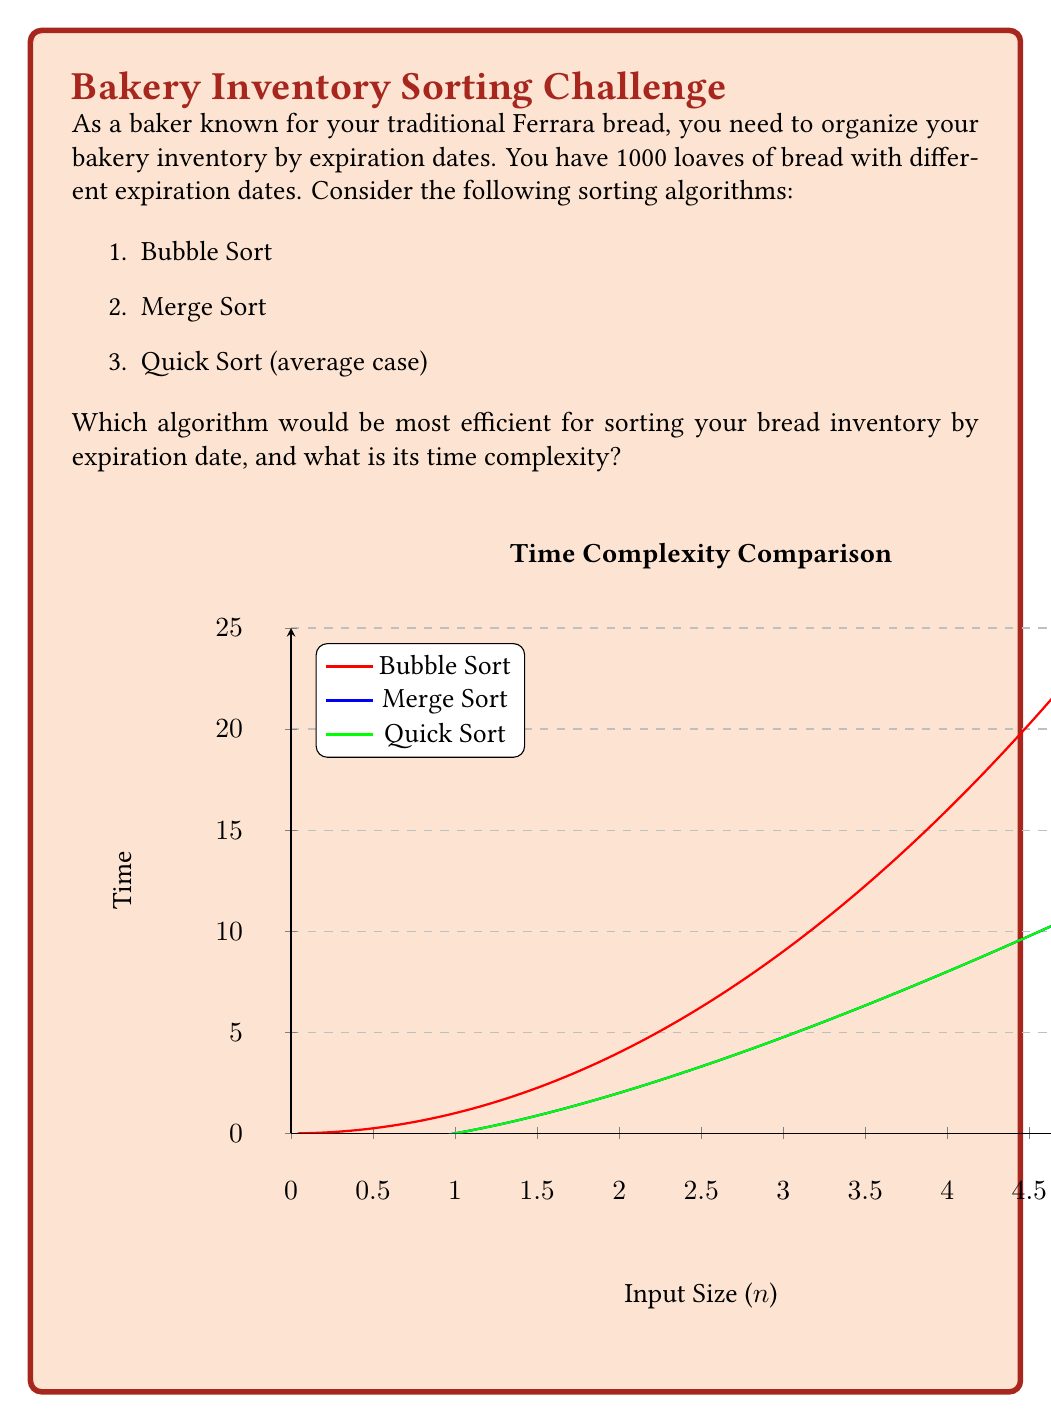Can you solve this math problem? Let's analyze the time complexity of each sorting algorithm:

1. Bubble Sort:
   - Time complexity: $O(n^2)$
   - For 1000 loaves: $1000^2 = 1,000,000$ operations

2. Merge Sort:
   - Time complexity: $O(n \log n)$
   - For 1000 loaves: $1000 \log_2 1000 \approx 9,966$ operations

3. Quick Sort (average case):
   - Time complexity: $O(n \log n)$
   - For 1000 loaves: $1000 \log_2 1000 \approx 9,966$ operations

Comparing these:
$$1,000,000 > 9,966 \approx 9,966$$

Both Merge Sort and Quick Sort have the same time complexity and are significantly faster than Bubble Sort for large inputs.

However, Quick Sort is often preferred in practice due to its in-place sorting capability (less memory usage) and good cache performance. It's particularly efficient for random access devices like arrays, which is likely how you'd store your bread inventory information.

Therefore, Quick Sort would be the most efficient algorithm for sorting your bread inventory by expiration date.
Answer: Quick Sort, with time complexity $O(n \log n)$ 